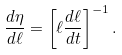Convert formula to latex. <formula><loc_0><loc_0><loc_500><loc_500>\frac { d \eta } { d \ell } = \left [ \ell \frac { d \ell } { d t } \right ] ^ { - 1 } .</formula> 